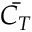<formula> <loc_0><loc_0><loc_500><loc_500>\bar { C _ { T } }</formula> 